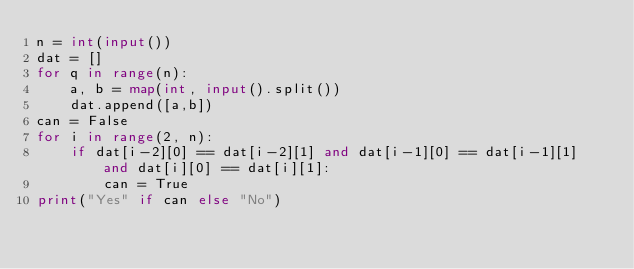Convert code to text. <code><loc_0><loc_0><loc_500><loc_500><_Python_>n = int(input())
dat = []
for q in range(n):
    a, b = map(int, input().split())
    dat.append([a,b])
can = False
for i in range(2, n):
    if dat[i-2][0] == dat[i-2][1] and dat[i-1][0] == dat[i-1][1] and dat[i][0] == dat[i][1]:
        can = True
print("Yes" if can else "No")
</code> 